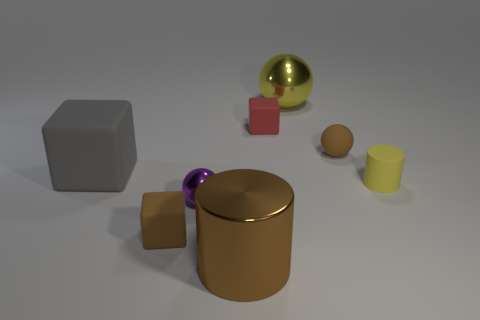Subtract all shiny spheres. How many spheres are left? 1 Add 1 brown cylinders. How many objects exist? 9 Subtract all cylinders. How many objects are left? 6 Add 1 tiny yellow rubber cylinders. How many tiny yellow rubber cylinders exist? 2 Subtract 1 brown cubes. How many objects are left? 7 Subtract all large metallic cylinders. Subtract all red shiny things. How many objects are left? 7 Add 3 big yellow objects. How many big yellow objects are left? 4 